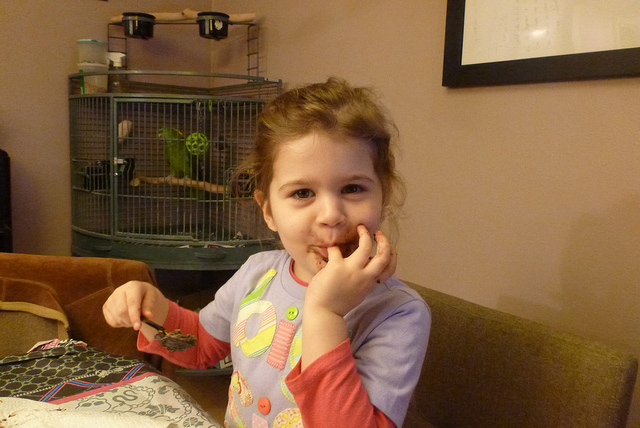<image>What does her shirt say? I cannot definitively say what her shirt says. It could say "big sis", "big bird", or "big sister". What does her shirt say? I don't know what her shirt says. It can be 'big sis', 'big', 'big bird', 'big sister' or 'pink'. 